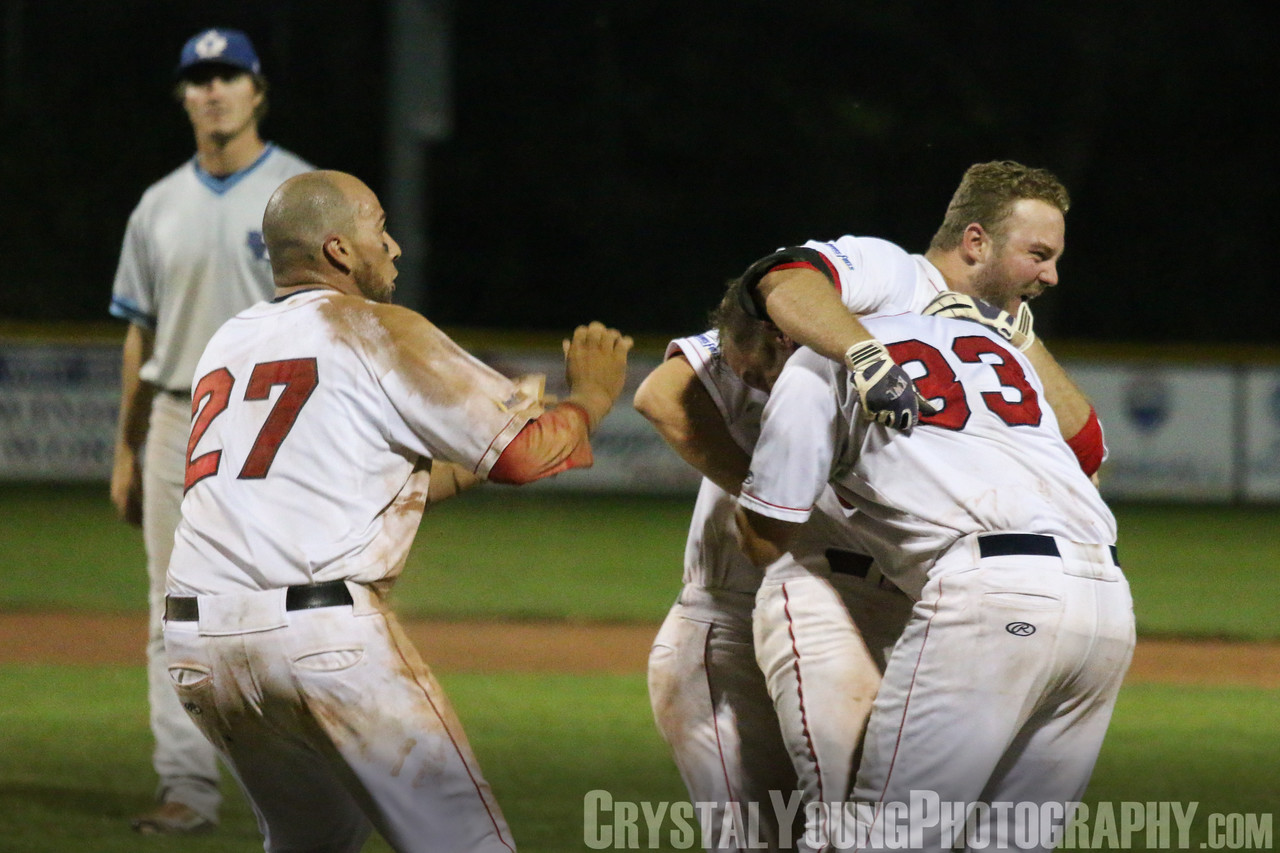How does the presence of the opposing player in the background enhance the story told by this image? The presence of the opposing player in the background significantly enhances the narrative captured by this image. His solitary stance, coupled with hands on hips and a seemingly dejected expression, creates a powerful contrast to the joyful celebration in the foreground. This juxtaposition not only amplifies the sense of triumph experienced by the celebrating team but also introduces a poignant element of defeat, highlighting the emotional highs and lows inherent in competitive sports. The image, therefore, becomes a more complete and compelling representation of the game's dramatic conclusion. 